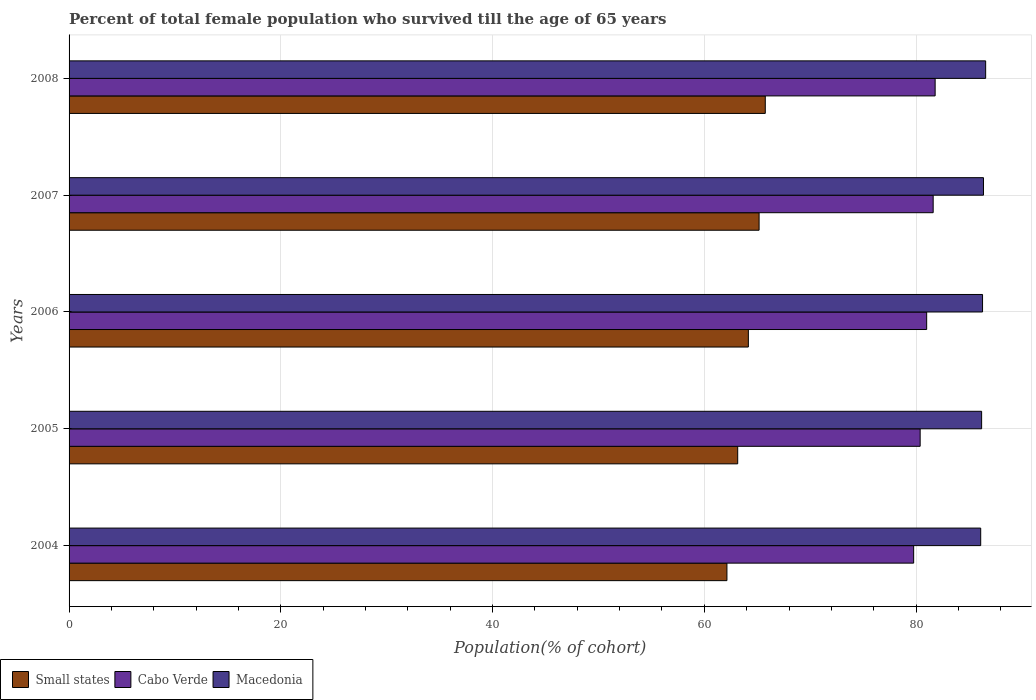How many groups of bars are there?
Your answer should be compact. 5. Are the number of bars per tick equal to the number of legend labels?
Offer a terse response. Yes. Are the number of bars on each tick of the Y-axis equal?
Your answer should be compact. Yes. What is the label of the 4th group of bars from the top?
Give a very brief answer. 2005. What is the percentage of total female population who survived till the age of 65 years in Small states in 2006?
Ensure brevity in your answer.  64.16. Across all years, what is the maximum percentage of total female population who survived till the age of 65 years in Small states?
Your response must be concise. 65.76. Across all years, what is the minimum percentage of total female population who survived till the age of 65 years in Cabo Verde?
Your response must be concise. 79.77. What is the total percentage of total female population who survived till the age of 65 years in Macedonia in the graph?
Offer a very short reply. 431.51. What is the difference between the percentage of total female population who survived till the age of 65 years in Small states in 2006 and that in 2007?
Offer a very short reply. -1.01. What is the difference between the percentage of total female population who survived till the age of 65 years in Small states in 2004 and the percentage of total female population who survived till the age of 65 years in Cabo Verde in 2005?
Offer a terse response. -18.25. What is the average percentage of total female population who survived till the age of 65 years in Small states per year?
Give a very brief answer. 64.08. In the year 2005, what is the difference between the percentage of total female population who survived till the age of 65 years in Small states and percentage of total female population who survived till the age of 65 years in Cabo Verde?
Your answer should be very brief. -17.23. What is the ratio of the percentage of total female population who survived till the age of 65 years in Macedonia in 2004 to that in 2008?
Your answer should be very brief. 0.99. Is the difference between the percentage of total female population who survived till the age of 65 years in Small states in 2005 and 2006 greater than the difference between the percentage of total female population who survived till the age of 65 years in Cabo Verde in 2005 and 2006?
Make the answer very short. No. What is the difference between the highest and the second highest percentage of total female population who survived till the age of 65 years in Cabo Verde?
Offer a very short reply. 0.19. What is the difference between the highest and the lowest percentage of total female population who survived till the age of 65 years in Cabo Verde?
Provide a succinct answer. 2.03. In how many years, is the percentage of total female population who survived till the age of 65 years in Macedonia greater than the average percentage of total female population who survived till the age of 65 years in Macedonia taken over all years?
Provide a short and direct response. 2. What does the 1st bar from the top in 2007 represents?
Your answer should be compact. Macedonia. What does the 2nd bar from the bottom in 2005 represents?
Your answer should be very brief. Cabo Verde. How many bars are there?
Your response must be concise. 15. Are all the bars in the graph horizontal?
Provide a short and direct response. Yes. Does the graph contain grids?
Offer a very short reply. Yes. Where does the legend appear in the graph?
Give a very brief answer. Bottom left. How many legend labels are there?
Provide a succinct answer. 3. How are the legend labels stacked?
Provide a short and direct response. Horizontal. What is the title of the graph?
Make the answer very short. Percent of total female population who survived till the age of 65 years. Does "Guatemala" appear as one of the legend labels in the graph?
Ensure brevity in your answer.  No. What is the label or title of the X-axis?
Ensure brevity in your answer.  Population(% of cohort). What is the Population(% of cohort) of Small states in 2004?
Make the answer very short. 62.14. What is the Population(% of cohort) of Cabo Verde in 2004?
Offer a very short reply. 79.77. What is the Population(% of cohort) of Macedonia in 2004?
Keep it short and to the point. 86.1. What is the Population(% of cohort) of Small states in 2005?
Keep it short and to the point. 63.15. What is the Population(% of cohort) in Cabo Verde in 2005?
Ensure brevity in your answer.  80.39. What is the Population(% of cohort) in Macedonia in 2005?
Make the answer very short. 86.19. What is the Population(% of cohort) in Small states in 2006?
Make the answer very short. 64.16. What is the Population(% of cohort) of Cabo Verde in 2006?
Give a very brief answer. 81. What is the Population(% of cohort) of Macedonia in 2006?
Offer a terse response. 86.28. What is the Population(% of cohort) of Small states in 2007?
Your answer should be very brief. 65.17. What is the Population(% of cohort) of Cabo Verde in 2007?
Ensure brevity in your answer.  81.61. What is the Population(% of cohort) of Macedonia in 2007?
Provide a succinct answer. 86.37. What is the Population(% of cohort) in Small states in 2008?
Offer a very short reply. 65.76. What is the Population(% of cohort) of Cabo Verde in 2008?
Your answer should be very brief. 81.8. What is the Population(% of cohort) in Macedonia in 2008?
Offer a terse response. 86.57. Across all years, what is the maximum Population(% of cohort) of Small states?
Make the answer very short. 65.76. Across all years, what is the maximum Population(% of cohort) of Cabo Verde?
Your answer should be compact. 81.8. Across all years, what is the maximum Population(% of cohort) of Macedonia?
Your answer should be compact. 86.57. Across all years, what is the minimum Population(% of cohort) in Small states?
Your answer should be compact. 62.14. Across all years, what is the minimum Population(% of cohort) in Cabo Verde?
Provide a succinct answer. 79.77. Across all years, what is the minimum Population(% of cohort) of Macedonia?
Give a very brief answer. 86.1. What is the total Population(% of cohort) in Small states in the graph?
Offer a terse response. 320.38. What is the total Population(% of cohort) of Cabo Verde in the graph?
Your answer should be compact. 404.57. What is the total Population(% of cohort) of Macedonia in the graph?
Keep it short and to the point. 431.51. What is the difference between the Population(% of cohort) in Small states in 2004 and that in 2005?
Offer a very short reply. -1.02. What is the difference between the Population(% of cohort) of Cabo Verde in 2004 and that in 2005?
Your response must be concise. -0.61. What is the difference between the Population(% of cohort) of Macedonia in 2004 and that in 2005?
Give a very brief answer. -0.09. What is the difference between the Population(% of cohort) in Small states in 2004 and that in 2006?
Offer a very short reply. -2.02. What is the difference between the Population(% of cohort) of Cabo Verde in 2004 and that in 2006?
Offer a terse response. -1.23. What is the difference between the Population(% of cohort) of Macedonia in 2004 and that in 2006?
Keep it short and to the point. -0.18. What is the difference between the Population(% of cohort) of Small states in 2004 and that in 2007?
Your answer should be compact. -3.04. What is the difference between the Population(% of cohort) in Cabo Verde in 2004 and that in 2007?
Offer a terse response. -1.84. What is the difference between the Population(% of cohort) in Macedonia in 2004 and that in 2007?
Your answer should be very brief. -0.26. What is the difference between the Population(% of cohort) in Small states in 2004 and that in 2008?
Offer a terse response. -3.62. What is the difference between the Population(% of cohort) of Cabo Verde in 2004 and that in 2008?
Ensure brevity in your answer.  -2.03. What is the difference between the Population(% of cohort) of Macedonia in 2004 and that in 2008?
Make the answer very short. -0.47. What is the difference between the Population(% of cohort) of Small states in 2005 and that in 2006?
Your answer should be very brief. -1.01. What is the difference between the Population(% of cohort) of Cabo Verde in 2005 and that in 2006?
Give a very brief answer. -0.61. What is the difference between the Population(% of cohort) of Macedonia in 2005 and that in 2006?
Offer a very short reply. -0.09. What is the difference between the Population(% of cohort) in Small states in 2005 and that in 2007?
Ensure brevity in your answer.  -2.02. What is the difference between the Population(% of cohort) in Cabo Verde in 2005 and that in 2007?
Your answer should be very brief. -1.23. What is the difference between the Population(% of cohort) of Macedonia in 2005 and that in 2007?
Provide a succinct answer. -0.18. What is the difference between the Population(% of cohort) in Small states in 2005 and that in 2008?
Your response must be concise. -2.6. What is the difference between the Population(% of cohort) of Cabo Verde in 2005 and that in 2008?
Offer a very short reply. -1.42. What is the difference between the Population(% of cohort) of Macedonia in 2005 and that in 2008?
Provide a succinct answer. -0.38. What is the difference between the Population(% of cohort) of Small states in 2006 and that in 2007?
Provide a succinct answer. -1.01. What is the difference between the Population(% of cohort) in Cabo Verde in 2006 and that in 2007?
Your response must be concise. -0.61. What is the difference between the Population(% of cohort) in Macedonia in 2006 and that in 2007?
Keep it short and to the point. -0.09. What is the difference between the Population(% of cohort) of Small states in 2006 and that in 2008?
Offer a terse response. -1.6. What is the difference between the Population(% of cohort) in Cabo Verde in 2006 and that in 2008?
Provide a short and direct response. -0.8. What is the difference between the Population(% of cohort) of Macedonia in 2006 and that in 2008?
Offer a very short reply. -0.29. What is the difference between the Population(% of cohort) in Small states in 2007 and that in 2008?
Your answer should be compact. -0.58. What is the difference between the Population(% of cohort) in Cabo Verde in 2007 and that in 2008?
Give a very brief answer. -0.19. What is the difference between the Population(% of cohort) of Macedonia in 2007 and that in 2008?
Ensure brevity in your answer.  -0.21. What is the difference between the Population(% of cohort) in Small states in 2004 and the Population(% of cohort) in Cabo Verde in 2005?
Your response must be concise. -18.25. What is the difference between the Population(% of cohort) in Small states in 2004 and the Population(% of cohort) in Macedonia in 2005?
Provide a succinct answer. -24.06. What is the difference between the Population(% of cohort) in Cabo Verde in 2004 and the Population(% of cohort) in Macedonia in 2005?
Offer a terse response. -6.42. What is the difference between the Population(% of cohort) of Small states in 2004 and the Population(% of cohort) of Cabo Verde in 2006?
Keep it short and to the point. -18.86. What is the difference between the Population(% of cohort) in Small states in 2004 and the Population(% of cohort) in Macedonia in 2006?
Ensure brevity in your answer.  -24.14. What is the difference between the Population(% of cohort) in Cabo Verde in 2004 and the Population(% of cohort) in Macedonia in 2006?
Your answer should be compact. -6.51. What is the difference between the Population(% of cohort) of Small states in 2004 and the Population(% of cohort) of Cabo Verde in 2007?
Your answer should be very brief. -19.48. What is the difference between the Population(% of cohort) in Small states in 2004 and the Population(% of cohort) in Macedonia in 2007?
Ensure brevity in your answer.  -24.23. What is the difference between the Population(% of cohort) in Cabo Verde in 2004 and the Population(% of cohort) in Macedonia in 2007?
Make the answer very short. -6.6. What is the difference between the Population(% of cohort) in Small states in 2004 and the Population(% of cohort) in Cabo Verde in 2008?
Offer a terse response. -19.67. What is the difference between the Population(% of cohort) of Small states in 2004 and the Population(% of cohort) of Macedonia in 2008?
Your answer should be very brief. -24.44. What is the difference between the Population(% of cohort) in Cabo Verde in 2004 and the Population(% of cohort) in Macedonia in 2008?
Provide a short and direct response. -6.8. What is the difference between the Population(% of cohort) of Small states in 2005 and the Population(% of cohort) of Cabo Verde in 2006?
Your answer should be very brief. -17.85. What is the difference between the Population(% of cohort) of Small states in 2005 and the Population(% of cohort) of Macedonia in 2006?
Make the answer very short. -23.13. What is the difference between the Population(% of cohort) of Cabo Verde in 2005 and the Population(% of cohort) of Macedonia in 2006?
Give a very brief answer. -5.89. What is the difference between the Population(% of cohort) in Small states in 2005 and the Population(% of cohort) in Cabo Verde in 2007?
Provide a short and direct response. -18.46. What is the difference between the Population(% of cohort) in Small states in 2005 and the Population(% of cohort) in Macedonia in 2007?
Your answer should be very brief. -23.21. What is the difference between the Population(% of cohort) in Cabo Verde in 2005 and the Population(% of cohort) in Macedonia in 2007?
Offer a terse response. -5.98. What is the difference between the Population(% of cohort) of Small states in 2005 and the Population(% of cohort) of Cabo Verde in 2008?
Keep it short and to the point. -18.65. What is the difference between the Population(% of cohort) of Small states in 2005 and the Population(% of cohort) of Macedonia in 2008?
Make the answer very short. -23.42. What is the difference between the Population(% of cohort) of Cabo Verde in 2005 and the Population(% of cohort) of Macedonia in 2008?
Offer a terse response. -6.19. What is the difference between the Population(% of cohort) in Small states in 2006 and the Population(% of cohort) in Cabo Verde in 2007?
Your answer should be compact. -17.46. What is the difference between the Population(% of cohort) in Small states in 2006 and the Population(% of cohort) in Macedonia in 2007?
Make the answer very short. -22.21. What is the difference between the Population(% of cohort) of Cabo Verde in 2006 and the Population(% of cohort) of Macedonia in 2007?
Offer a terse response. -5.37. What is the difference between the Population(% of cohort) in Small states in 2006 and the Population(% of cohort) in Cabo Verde in 2008?
Offer a very short reply. -17.64. What is the difference between the Population(% of cohort) of Small states in 2006 and the Population(% of cohort) of Macedonia in 2008?
Make the answer very short. -22.41. What is the difference between the Population(% of cohort) of Cabo Verde in 2006 and the Population(% of cohort) of Macedonia in 2008?
Provide a short and direct response. -5.57. What is the difference between the Population(% of cohort) in Small states in 2007 and the Population(% of cohort) in Cabo Verde in 2008?
Give a very brief answer. -16.63. What is the difference between the Population(% of cohort) in Small states in 2007 and the Population(% of cohort) in Macedonia in 2008?
Your response must be concise. -21.4. What is the difference between the Population(% of cohort) in Cabo Verde in 2007 and the Population(% of cohort) in Macedonia in 2008?
Keep it short and to the point. -4.96. What is the average Population(% of cohort) of Small states per year?
Your answer should be very brief. 64.08. What is the average Population(% of cohort) of Cabo Verde per year?
Your response must be concise. 80.91. What is the average Population(% of cohort) in Macedonia per year?
Your answer should be compact. 86.3. In the year 2004, what is the difference between the Population(% of cohort) in Small states and Population(% of cohort) in Cabo Verde?
Make the answer very short. -17.64. In the year 2004, what is the difference between the Population(% of cohort) of Small states and Population(% of cohort) of Macedonia?
Your answer should be compact. -23.97. In the year 2004, what is the difference between the Population(% of cohort) in Cabo Verde and Population(% of cohort) in Macedonia?
Provide a short and direct response. -6.33. In the year 2005, what is the difference between the Population(% of cohort) of Small states and Population(% of cohort) of Cabo Verde?
Offer a very short reply. -17.23. In the year 2005, what is the difference between the Population(% of cohort) in Small states and Population(% of cohort) in Macedonia?
Your answer should be very brief. -23.04. In the year 2005, what is the difference between the Population(% of cohort) of Cabo Verde and Population(% of cohort) of Macedonia?
Provide a succinct answer. -5.81. In the year 2006, what is the difference between the Population(% of cohort) of Small states and Population(% of cohort) of Cabo Verde?
Your response must be concise. -16.84. In the year 2006, what is the difference between the Population(% of cohort) in Small states and Population(% of cohort) in Macedonia?
Provide a short and direct response. -22.12. In the year 2006, what is the difference between the Population(% of cohort) in Cabo Verde and Population(% of cohort) in Macedonia?
Give a very brief answer. -5.28. In the year 2007, what is the difference between the Population(% of cohort) of Small states and Population(% of cohort) of Cabo Verde?
Offer a terse response. -16.44. In the year 2007, what is the difference between the Population(% of cohort) of Small states and Population(% of cohort) of Macedonia?
Make the answer very short. -21.19. In the year 2007, what is the difference between the Population(% of cohort) of Cabo Verde and Population(% of cohort) of Macedonia?
Provide a succinct answer. -4.75. In the year 2008, what is the difference between the Population(% of cohort) of Small states and Population(% of cohort) of Cabo Verde?
Provide a succinct answer. -16.04. In the year 2008, what is the difference between the Population(% of cohort) in Small states and Population(% of cohort) in Macedonia?
Keep it short and to the point. -20.82. In the year 2008, what is the difference between the Population(% of cohort) of Cabo Verde and Population(% of cohort) of Macedonia?
Your answer should be compact. -4.77. What is the ratio of the Population(% of cohort) of Small states in 2004 to that in 2005?
Your answer should be compact. 0.98. What is the ratio of the Population(% of cohort) in Cabo Verde in 2004 to that in 2005?
Keep it short and to the point. 0.99. What is the ratio of the Population(% of cohort) in Macedonia in 2004 to that in 2005?
Offer a very short reply. 1. What is the ratio of the Population(% of cohort) of Small states in 2004 to that in 2006?
Provide a succinct answer. 0.97. What is the ratio of the Population(% of cohort) in Cabo Verde in 2004 to that in 2006?
Give a very brief answer. 0.98. What is the ratio of the Population(% of cohort) in Macedonia in 2004 to that in 2006?
Give a very brief answer. 1. What is the ratio of the Population(% of cohort) in Small states in 2004 to that in 2007?
Your response must be concise. 0.95. What is the ratio of the Population(% of cohort) of Cabo Verde in 2004 to that in 2007?
Ensure brevity in your answer.  0.98. What is the ratio of the Population(% of cohort) in Small states in 2004 to that in 2008?
Your answer should be very brief. 0.94. What is the ratio of the Population(% of cohort) in Cabo Verde in 2004 to that in 2008?
Offer a very short reply. 0.98. What is the ratio of the Population(% of cohort) of Macedonia in 2004 to that in 2008?
Make the answer very short. 0.99. What is the ratio of the Population(% of cohort) of Small states in 2005 to that in 2006?
Your answer should be compact. 0.98. What is the ratio of the Population(% of cohort) of Cabo Verde in 2005 to that in 2006?
Make the answer very short. 0.99. What is the ratio of the Population(% of cohort) of Cabo Verde in 2005 to that in 2007?
Provide a succinct answer. 0.98. What is the ratio of the Population(% of cohort) in Macedonia in 2005 to that in 2007?
Provide a short and direct response. 1. What is the ratio of the Population(% of cohort) of Small states in 2005 to that in 2008?
Offer a very short reply. 0.96. What is the ratio of the Population(% of cohort) in Cabo Verde in 2005 to that in 2008?
Provide a short and direct response. 0.98. What is the ratio of the Population(% of cohort) of Small states in 2006 to that in 2007?
Your answer should be compact. 0.98. What is the ratio of the Population(% of cohort) in Cabo Verde in 2006 to that in 2007?
Offer a terse response. 0.99. What is the ratio of the Population(% of cohort) in Macedonia in 2006 to that in 2007?
Your response must be concise. 1. What is the ratio of the Population(% of cohort) of Small states in 2006 to that in 2008?
Your answer should be compact. 0.98. What is the ratio of the Population(% of cohort) of Cabo Verde in 2006 to that in 2008?
Your answer should be compact. 0.99. What is the ratio of the Population(% of cohort) in Small states in 2007 to that in 2008?
Offer a terse response. 0.99. What is the ratio of the Population(% of cohort) of Cabo Verde in 2007 to that in 2008?
Offer a terse response. 1. What is the difference between the highest and the second highest Population(% of cohort) in Small states?
Make the answer very short. 0.58. What is the difference between the highest and the second highest Population(% of cohort) in Cabo Verde?
Provide a short and direct response. 0.19. What is the difference between the highest and the second highest Population(% of cohort) of Macedonia?
Offer a very short reply. 0.21. What is the difference between the highest and the lowest Population(% of cohort) of Small states?
Your answer should be compact. 3.62. What is the difference between the highest and the lowest Population(% of cohort) of Cabo Verde?
Ensure brevity in your answer.  2.03. What is the difference between the highest and the lowest Population(% of cohort) of Macedonia?
Offer a very short reply. 0.47. 